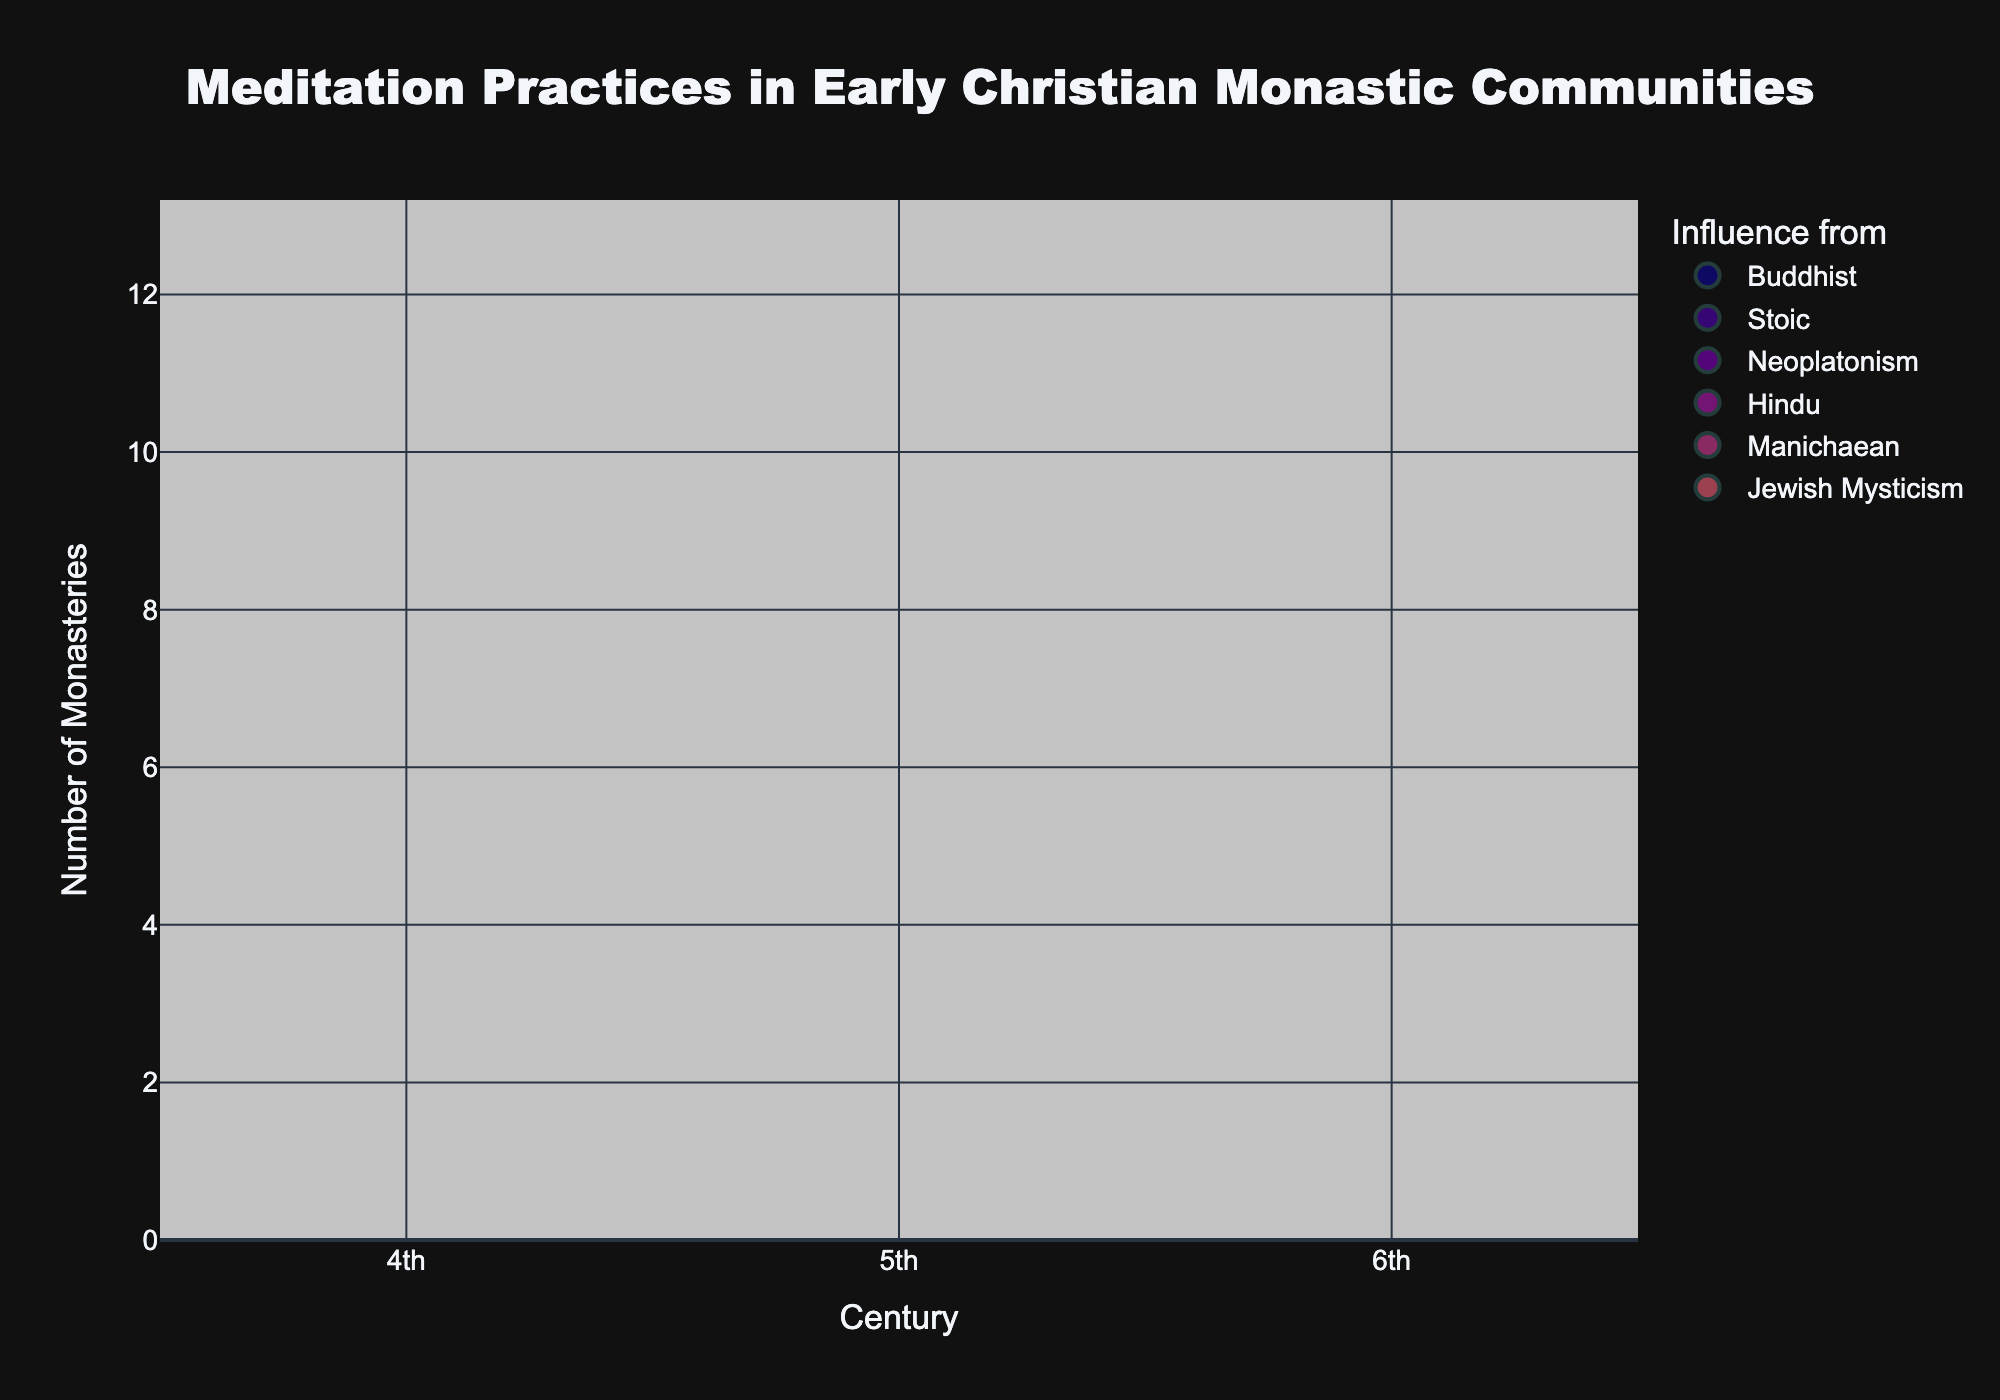How many unique geographical areas are represented on the chart? By observing the bubble chart, we see distinct bubbles for different geographical areas. Counting the unique geographical areas shown in the chart gives us the answer.
Answer: 7 Which geographical area has the largest number of monasteries practicing meditation? Look for the largest bubble on the y-axis, which represents the number of monasteries. This will show the area with the most monasteries practicing meditation.
Answer: Alexandria (Egypt) In which century did monasteries in Rome practice Breathing Techniques? Identify the bubble labeled 'Rome' and check its position on the x-axis to see which century it corresponds to.
Answer: 5th Compare the number of monasteries practicing Contemplative Prayer in Alexandria with those in Lerins. What is the difference? Find and compare the size of the bubbles labeled 'Alexandria' and 'Lerins', respectively, since Contemplative Prayer is mentioned in both locations. The difference in the number of monasteries is the difference in bubble sizes.
Answer: 7 Which meditation practice was introduced in the century represented by the 6th position on the x-axis? Find the bubble positioned on the 6th century mark on the x-axis and look for the label indicating the meditation practice for that region.
Answer: Repetitive Prayer How many monasteries practiced mindfulness meditation, and which geographical area does it relate to? Look for the bubble associated with Mindfulness Meditation and note the size (number of monasteries) and the geographical area label.
Answer: 8, Cappadocia (Turkey) What is the common influence source of meditation practices in Alexandria and Mount Athos? Identify the influence source from the bubble labels for both Alexandria and Mount Athos and see if they match.
Answer: Buddhist Which century shows the least variety in the types of meditation practices, and how many different practices are there? Observe the bubbles across different centuries and count the types of meditation practices within each century. The century with the least variety will have the fewest distinct practices.
Answer: 4th, 2 practices Determine the average number of monasteries per geographical area. Sum the number of monasteries from all areas and divide by the total number of geographical areas.
Answer: 8.14 Between Alexandria and Antioch, which has a greater influence by non-Buddhist traditions, and by how many monasteries? Compare the influence sources for Alexandria and Antioch and count the number of monasteries influenced by non-Buddhist traditions. Subtract the numbers to find the difference.
Answer: Antioch by 7 